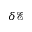Convert formula to latex. <formula><loc_0><loc_0><loc_500><loc_500>\delta \mathcal { E }</formula> 